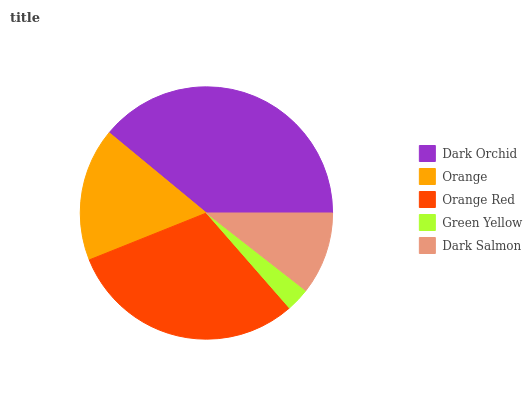Is Green Yellow the minimum?
Answer yes or no. Yes. Is Dark Orchid the maximum?
Answer yes or no. Yes. Is Orange the minimum?
Answer yes or no. No. Is Orange the maximum?
Answer yes or no. No. Is Dark Orchid greater than Orange?
Answer yes or no. Yes. Is Orange less than Dark Orchid?
Answer yes or no. Yes. Is Orange greater than Dark Orchid?
Answer yes or no. No. Is Dark Orchid less than Orange?
Answer yes or no. No. Is Orange the high median?
Answer yes or no. Yes. Is Orange the low median?
Answer yes or no. Yes. Is Green Yellow the high median?
Answer yes or no. No. Is Dark Orchid the low median?
Answer yes or no. No. 